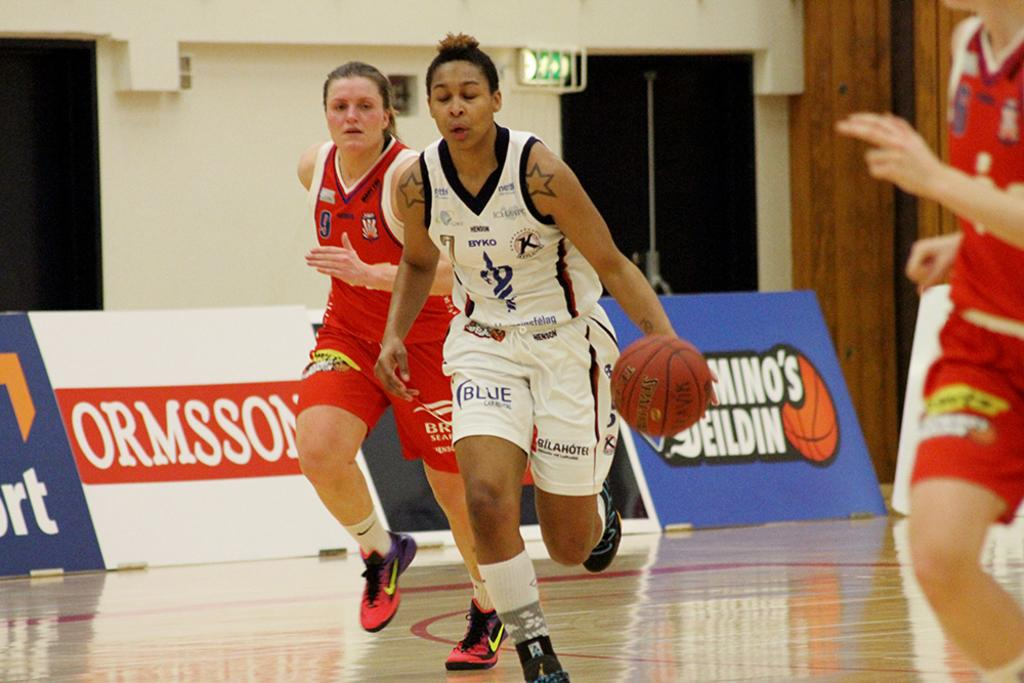<image>
Offer a succinct explanation of the picture presented. Basketball player with the word BLUE on his shorts is dribbling. 